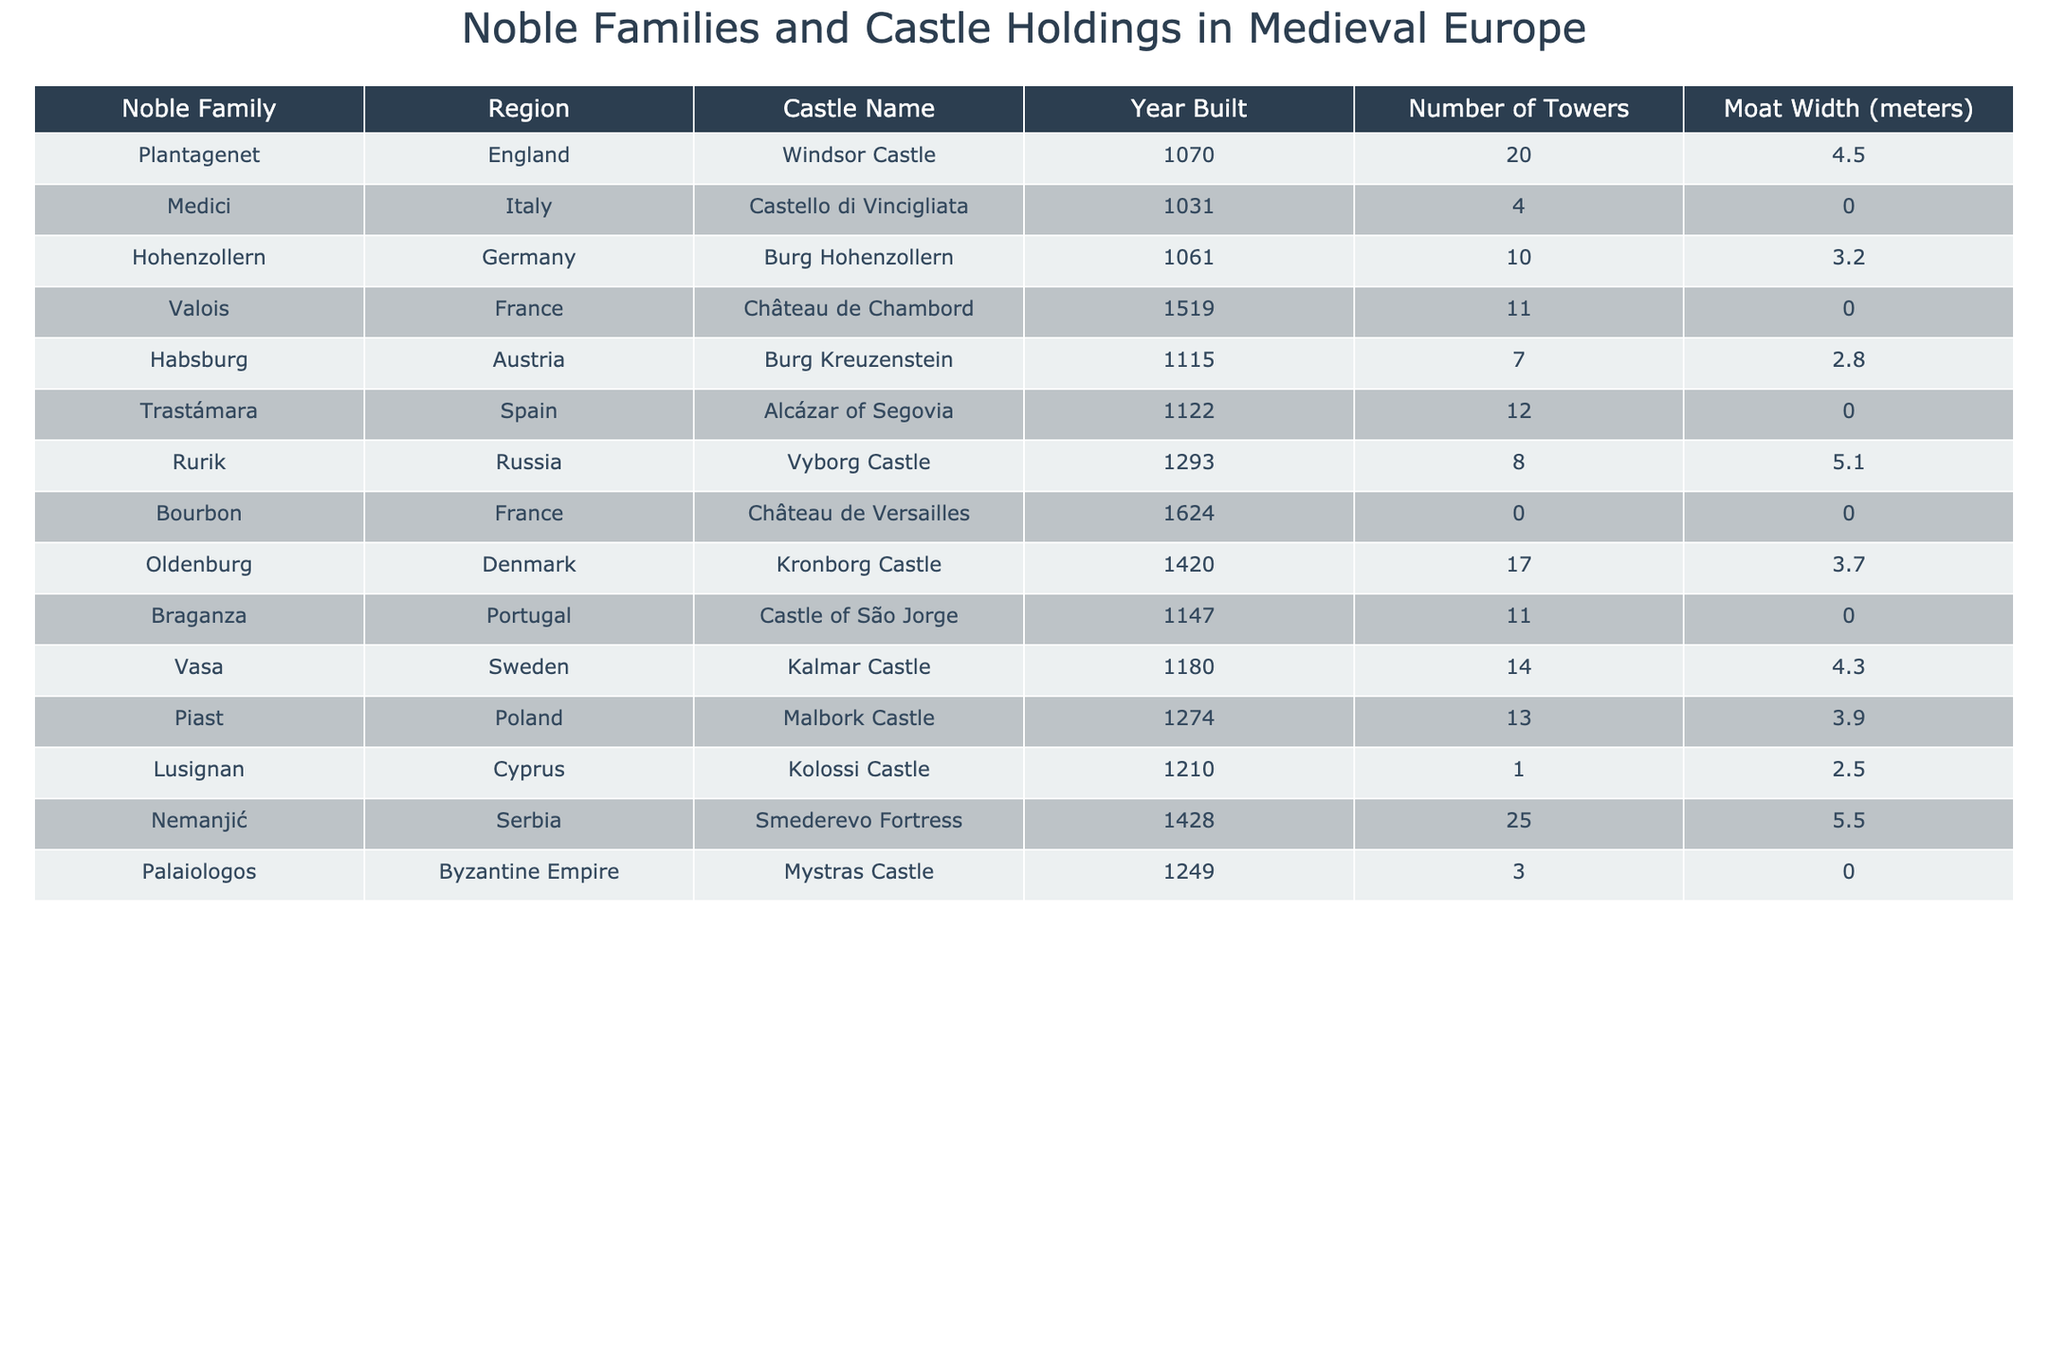What is the name of the castle owned by the House of Medici? The table lists the noble families and their associated castles. By finding the Medici family in the table, we see that the corresponding castle is 'Castello di Vincigliata.'
Answer: Castello di Vincigliata Which region has the tallest castle and how many towers does it have? A lookup of the 'Number of Towers' column shows that the Habsburg family has Burg Kreuzenstein listed with 7 towers, while Nemanjić from Serbia has Smederevo Fortress with 25 towers, which is the tallest. Therefore, the region is Serbia.
Answer: Serbia, 25 towers How many castles listed have a moat width of 0 meters? To find the number of castles with a moat width of 0 meters, I will go through the 'Moat Width' column and count: Bourg de Versailles and Alcázar of Segovia are the two that meet this criterion. Thus, the total is 2.
Answer: 2 What is the total number of towers across all castles? By adding the 'Number of Towers' values from each castle, I calculate: 20 (Windsor) + 4 (Castello di Vincigliata) + 10 (Burg Hohenzollern) + 11 (Château de Chambord) + 7 (Burg Kreuzenstein) + 12 (Alcázar of Segovia) + 8 (Vyborg) + 0 (Château de Versailles) + 17 (Kronborg) + 11 (Castle of São Jorge) + 14 (Kalmar) + 13 (Malbork) + 1 (Kolossi) + 25 (Smederevo) + 3 (Mystras) =  345.
Answer: 345 Are there more castles built in the 13th century than in the 11th century? I will count the castles built in the 11th century (3 castles) and the 13th century (3 castles). Since both counts are equal, the answer is no, there are not more castles built in the 13th century than in the 11th century.
Answer: No Which family has the castle with the widest moat and what is that width? Reviewing the 'Moat Width' column reveals that the widest moat is associated with the Nemanjić family at 5.5 meters with their Smederevo Fortress.
Answer: Nemanjić, 5.5 meters What is the average number of towers built in castles from the regions of France? From the table, the castles in France are Château de Chambord (11 towers) and Château de Versailles (0 towers). I calculate the average: (0 + 11) / 2 = 5.5. Thus, the average number of towers in French castles is 5.5.
Answer: 5.5 Which noble family built their castle earliest, and what is the name of the castle? The earliest castle built is Windsor Castle in 1070 by the Plantagenet family. Checking the 'Year Built' column confirms that there is no earlier castle than this.
Answer: Plantagenet, Windsor Castle Is there a castle from the Byzantine Empire, and if so, what is its name? The table includes a row for the Byzantine Empire, which shows Mystras Castle listed under the Palaiologos family. Therefore, yes, there is a castle from the Byzantine Empire.
Answer: Yes, Mystras Castle How many regions have castles with more than 10 towers? Checking the 'Number of Towers' column reveals that the following families have more than 10 towers: Plantagenet (20), Trastámara (12), Vasa (14), Piast (13), and Nemanjić (25). This results in a total of 5 regions.
Answer: 5 